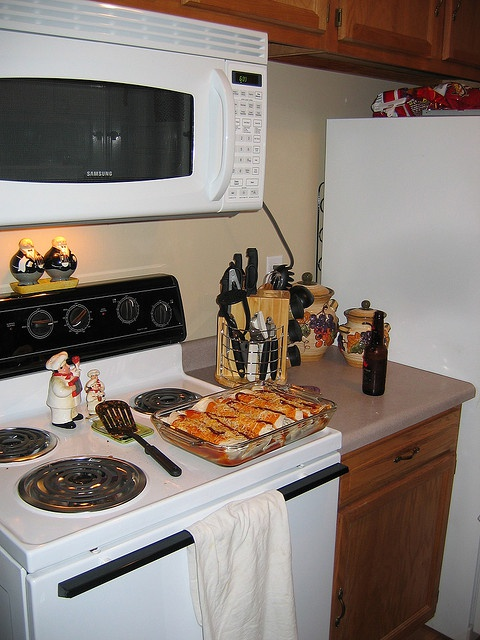Describe the objects in this image and their specific colors. I can see oven in gray, lightgray, black, and darkgray tones, microwave in gray, lightgray, black, and darkgray tones, refrigerator in gray, darkgray, black, and lightgray tones, and bottle in gray, black, and maroon tones in this image. 